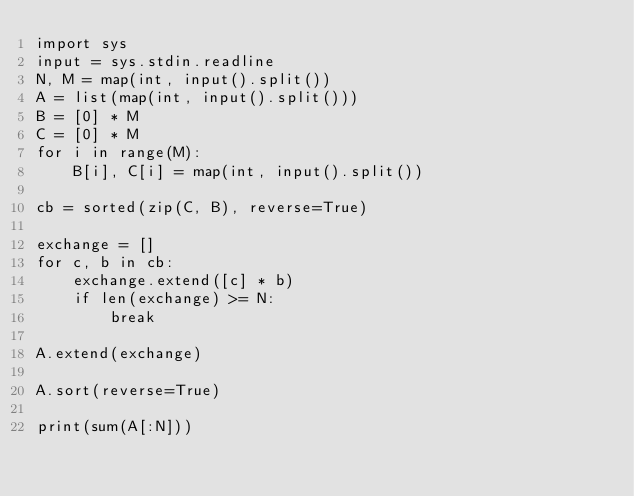<code> <loc_0><loc_0><loc_500><loc_500><_Python_>import sys
input = sys.stdin.readline
N, M = map(int, input().split())
A = list(map(int, input().split()))
B = [0] * M
C = [0] * M
for i in range(M):
    B[i], C[i] = map(int, input().split())

cb = sorted(zip(C, B), reverse=True)

exchange = []
for c, b in cb:
    exchange.extend([c] * b)
    if len(exchange) >= N:
        break

A.extend(exchange)

A.sort(reverse=True)

print(sum(A[:N]))</code> 